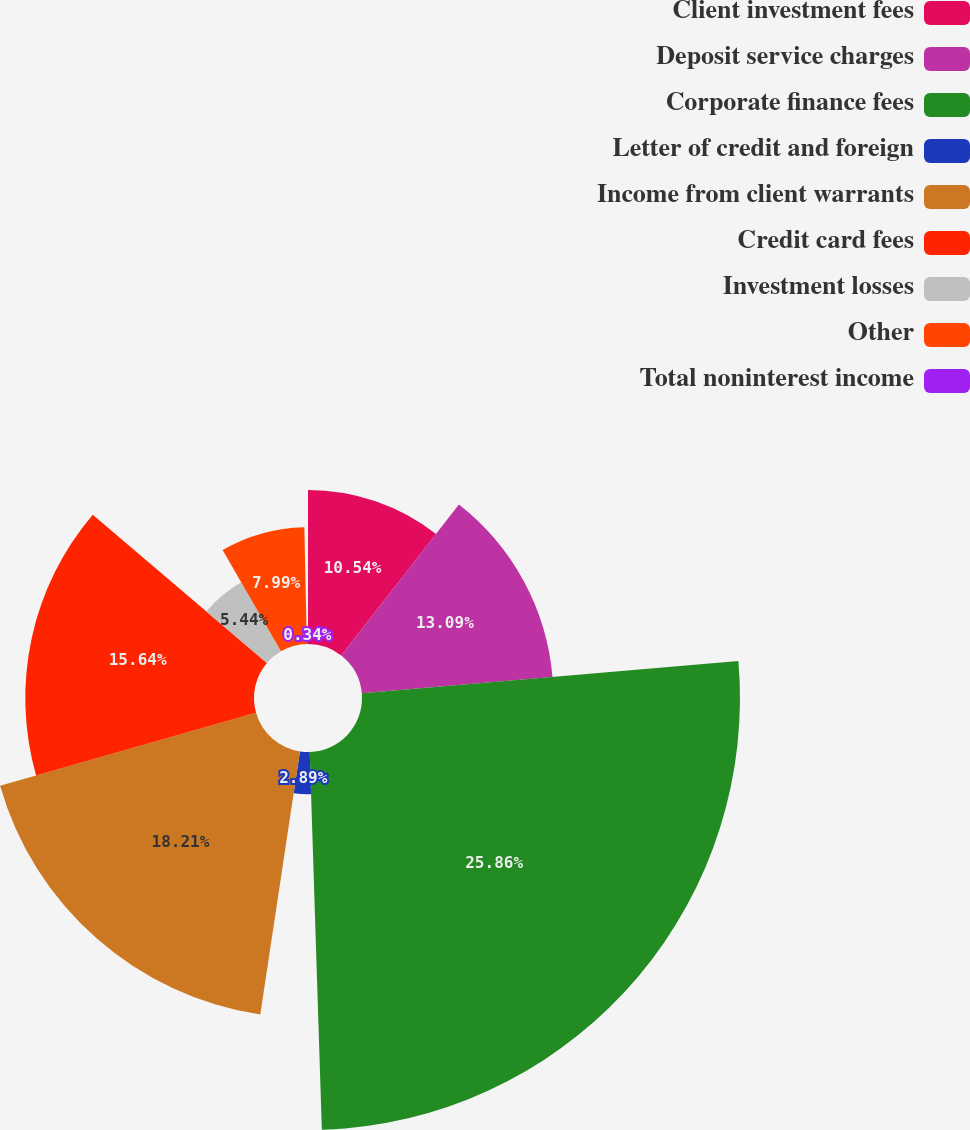Convert chart. <chart><loc_0><loc_0><loc_500><loc_500><pie_chart><fcel>Client investment fees<fcel>Deposit service charges<fcel>Corporate finance fees<fcel>Letter of credit and foreign<fcel>Income from client warrants<fcel>Credit card fees<fcel>Investment losses<fcel>Other<fcel>Total noninterest income<nl><fcel>10.54%<fcel>13.09%<fcel>25.85%<fcel>2.89%<fcel>18.2%<fcel>15.64%<fcel>5.44%<fcel>7.99%<fcel>0.34%<nl></chart> 